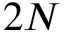<formula> <loc_0><loc_0><loc_500><loc_500>2 N</formula> 